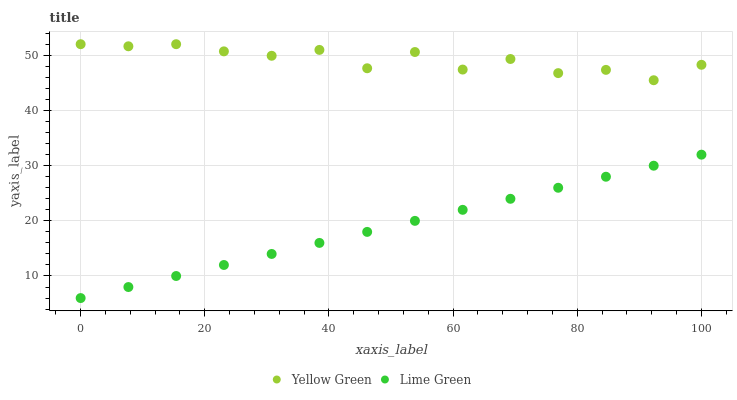Does Lime Green have the minimum area under the curve?
Answer yes or no. Yes. Does Yellow Green have the maximum area under the curve?
Answer yes or no. Yes. Does Yellow Green have the minimum area under the curve?
Answer yes or no. No. Is Lime Green the smoothest?
Answer yes or no. Yes. Is Yellow Green the roughest?
Answer yes or no. Yes. Is Yellow Green the smoothest?
Answer yes or no. No. Does Lime Green have the lowest value?
Answer yes or no. Yes. Does Yellow Green have the lowest value?
Answer yes or no. No. Does Yellow Green have the highest value?
Answer yes or no. Yes. Is Lime Green less than Yellow Green?
Answer yes or no. Yes. Is Yellow Green greater than Lime Green?
Answer yes or no. Yes. Does Lime Green intersect Yellow Green?
Answer yes or no. No. 